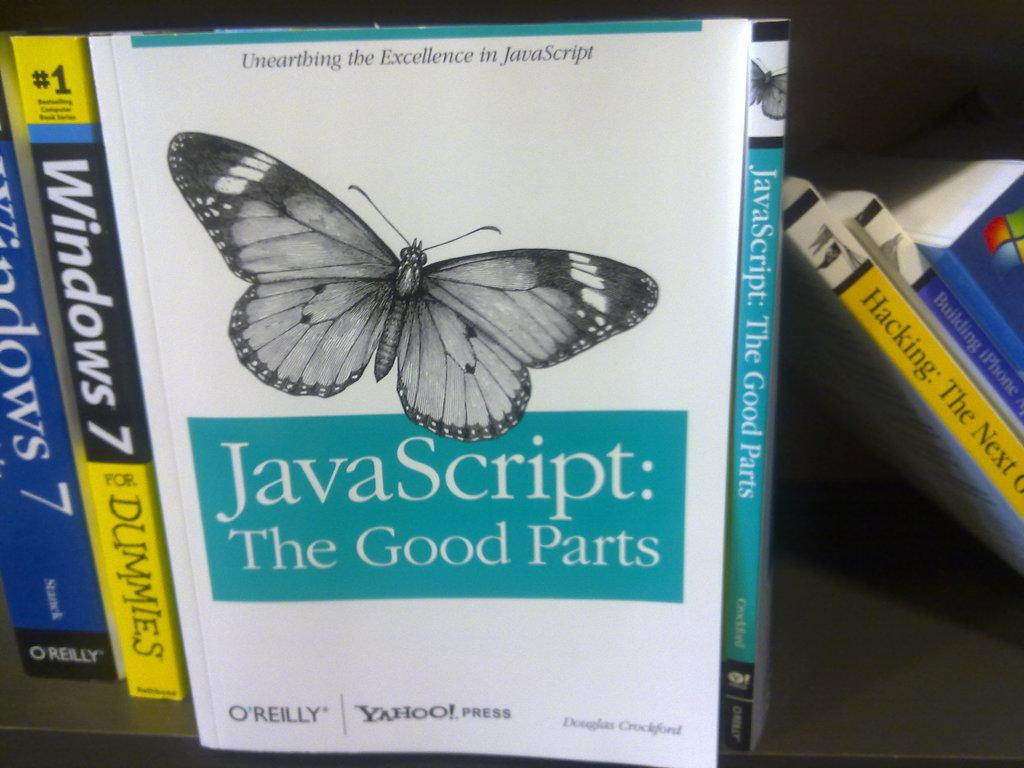What objects can be seen in the image? There are books in the image. How are the books organized in the image? The books are arranged in a cupboard. What type of reward can be seen on top of the mountain in the image? There is no mountain or reward present in the image; it only features books arranged in a cupboard. How much dust is visible on the books in the image? The provided facts do not mention any dust on the books, so we cannot determine the amount of dust from the image. 